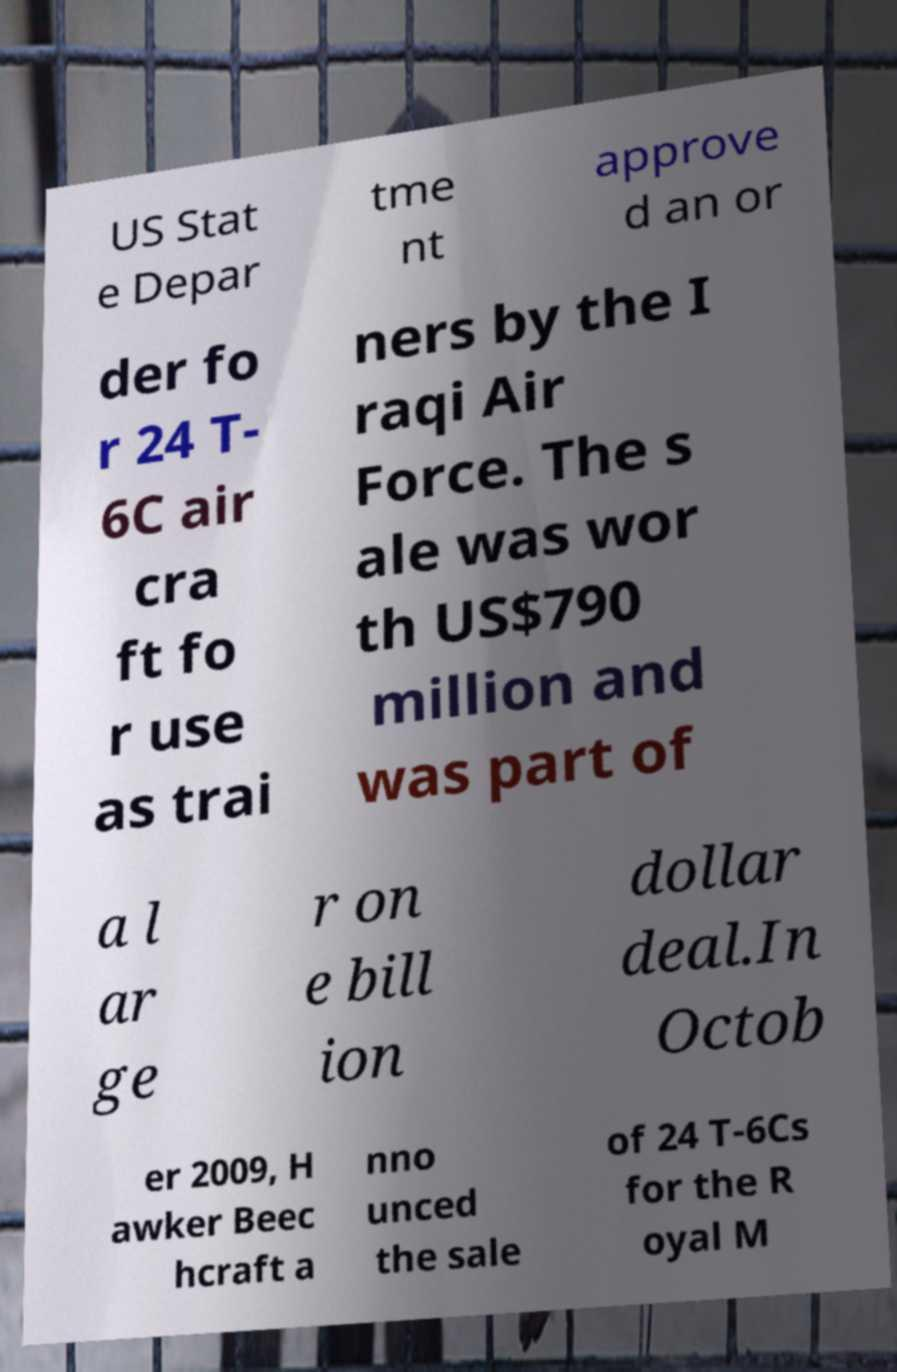I need the written content from this picture converted into text. Can you do that? US Stat e Depar tme nt approve d an or der fo r 24 T- 6C air cra ft fo r use as trai ners by the I raqi Air Force. The s ale was wor th US$790 million and was part of a l ar ge r on e bill ion dollar deal.In Octob er 2009, H awker Beec hcraft a nno unced the sale of 24 T-6Cs for the R oyal M 